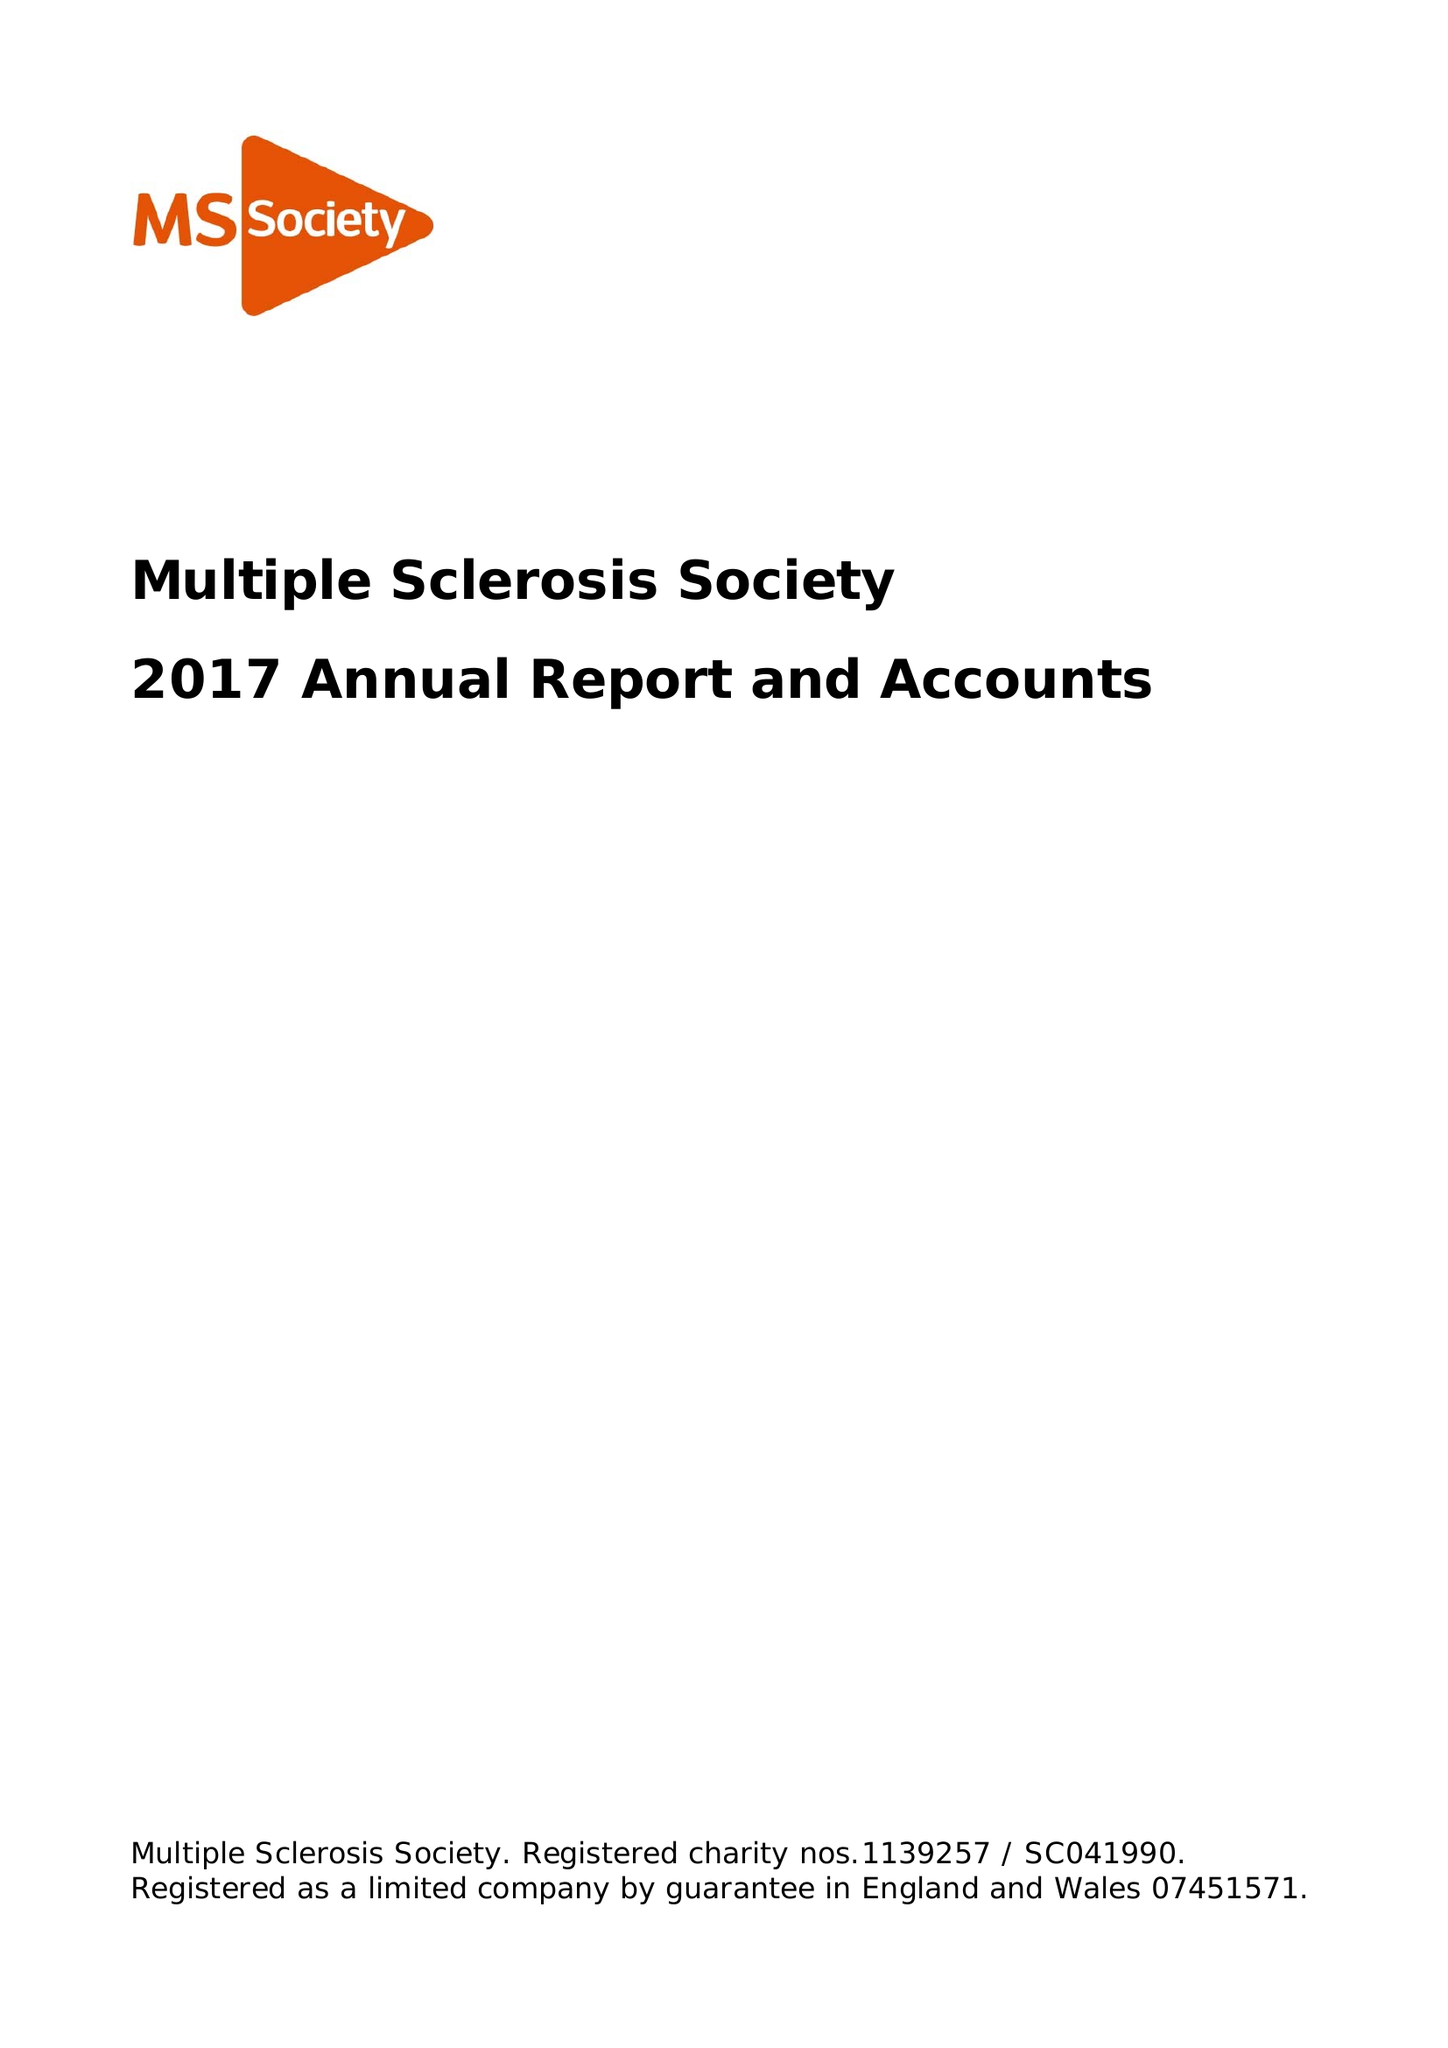What is the value for the address__post_town?
Answer the question using a single word or phrase. LONDON 